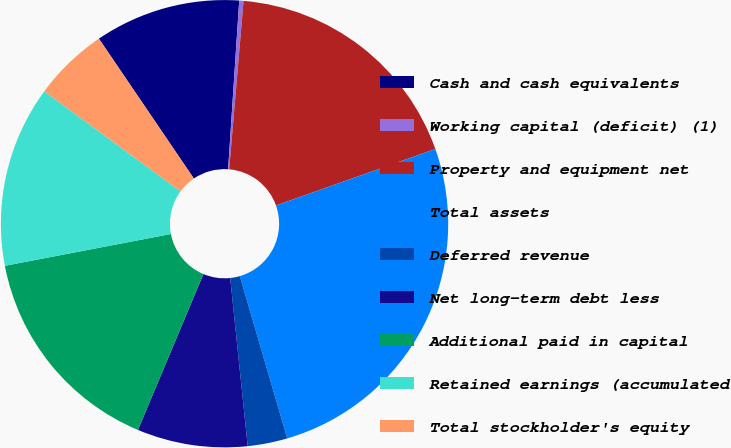Convert chart. <chart><loc_0><loc_0><loc_500><loc_500><pie_chart><fcel>Cash and cash equivalents<fcel>Working capital (deficit) (1)<fcel>Property and equipment net<fcel>Total assets<fcel>Deferred revenue<fcel>Net long-term debt less<fcel>Additional paid in capital<fcel>Retained earnings (accumulated<fcel>Total stockholder's equity<nl><fcel>10.54%<fcel>0.31%<fcel>18.22%<fcel>25.9%<fcel>2.87%<fcel>7.98%<fcel>15.66%<fcel>13.1%<fcel>5.42%<nl></chart> 